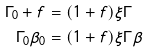<formula> <loc_0><loc_0><loc_500><loc_500>\Gamma _ { 0 } + f & = ( 1 + f ) \xi \Gamma \\ \Gamma _ { 0 } \beta _ { 0 } & = ( 1 + f ) \xi \Gamma \beta</formula> 